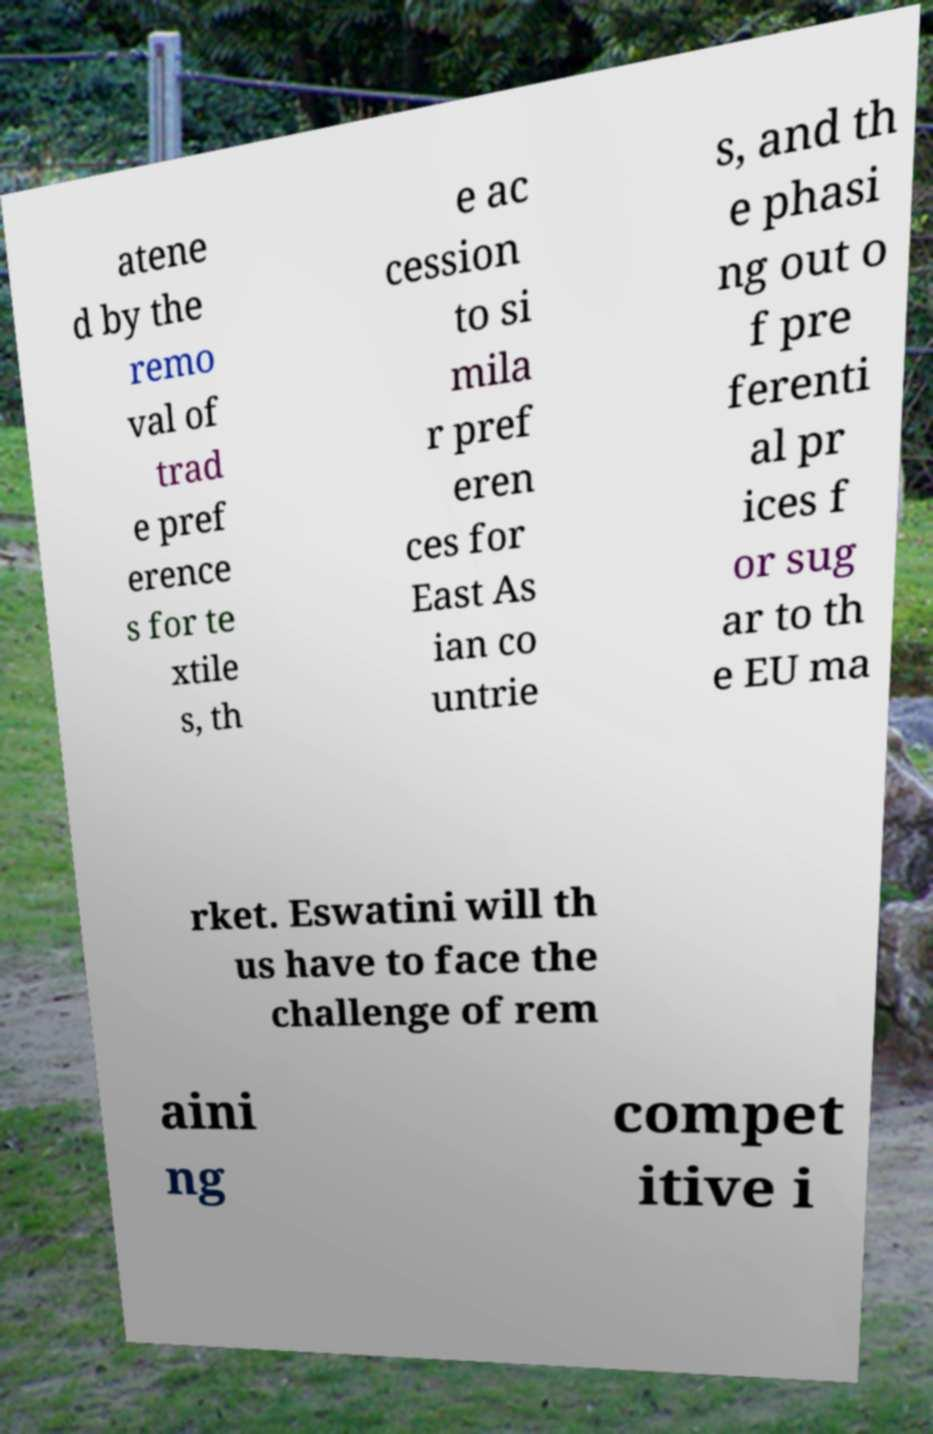I need the written content from this picture converted into text. Can you do that? atene d by the remo val of trad e pref erence s for te xtile s, th e ac cession to si mila r pref eren ces for East As ian co untrie s, and th e phasi ng out o f pre ferenti al pr ices f or sug ar to th e EU ma rket. Eswatini will th us have to face the challenge of rem aini ng compet itive i 